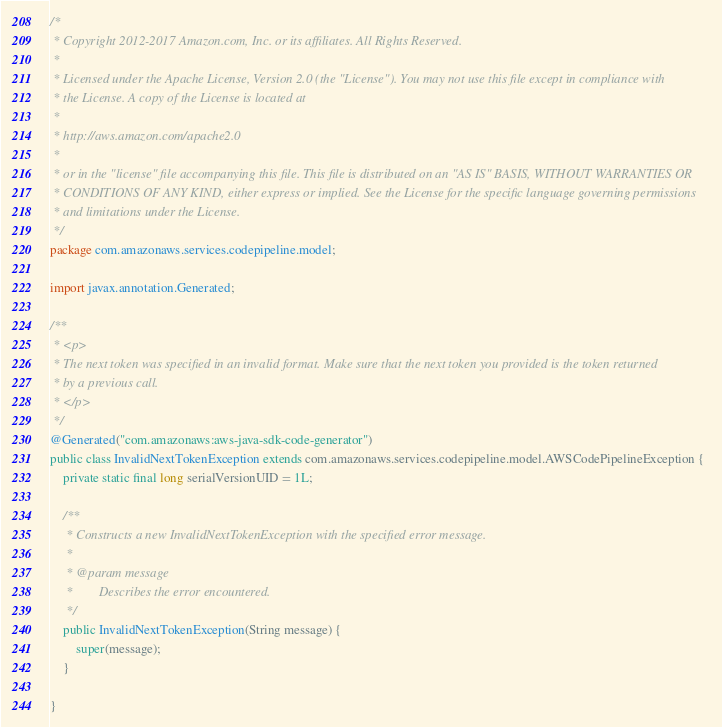<code> <loc_0><loc_0><loc_500><loc_500><_Java_>/*
 * Copyright 2012-2017 Amazon.com, Inc. or its affiliates. All Rights Reserved.
 * 
 * Licensed under the Apache License, Version 2.0 (the "License"). You may not use this file except in compliance with
 * the License. A copy of the License is located at
 * 
 * http://aws.amazon.com/apache2.0
 * 
 * or in the "license" file accompanying this file. This file is distributed on an "AS IS" BASIS, WITHOUT WARRANTIES OR
 * CONDITIONS OF ANY KIND, either express or implied. See the License for the specific language governing permissions
 * and limitations under the License.
 */
package com.amazonaws.services.codepipeline.model;

import javax.annotation.Generated;

/**
 * <p>
 * The next token was specified in an invalid format. Make sure that the next token you provided is the token returned
 * by a previous call.
 * </p>
 */
@Generated("com.amazonaws:aws-java-sdk-code-generator")
public class InvalidNextTokenException extends com.amazonaws.services.codepipeline.model.AWSCodePipelineException {
    private static final long serialVersionUID = 1L;

    /**
     * Constructs a new InvalidNextTokenException with the specified error message.
     *
     * @param message
     *        Describes the error encountered.
     */
    public InvalidNextTokenException(String message) {
        super(message);
    }

}
</code> 